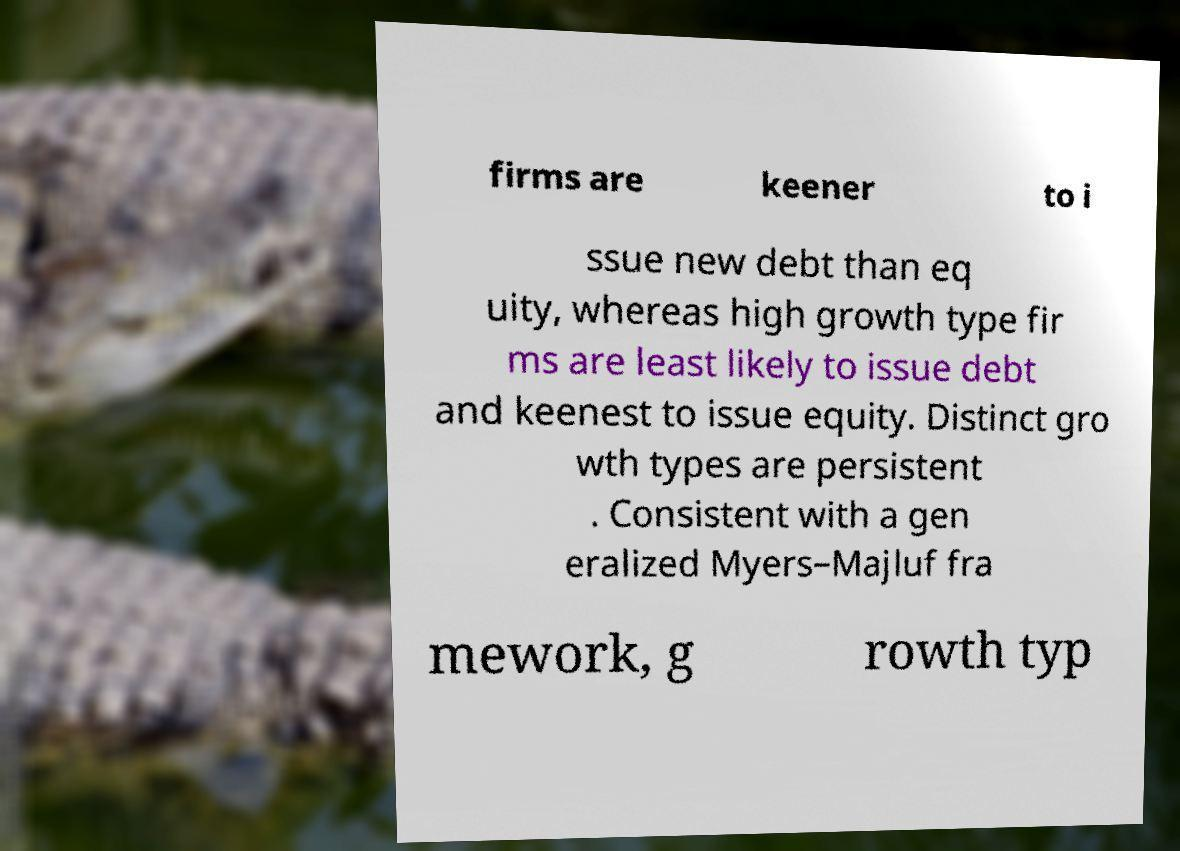For documentation purposes, I need the text within this image transcribed. Could you provide that? firms are keener to i ssue new debt than eq uity, whereas high growth type fir ms are least likely to issue debt and keenest to issue equity. Distinct gro wth types are persistent . Consistent with a gen eralized Myers–Majluf fra mework, g rowth typ 